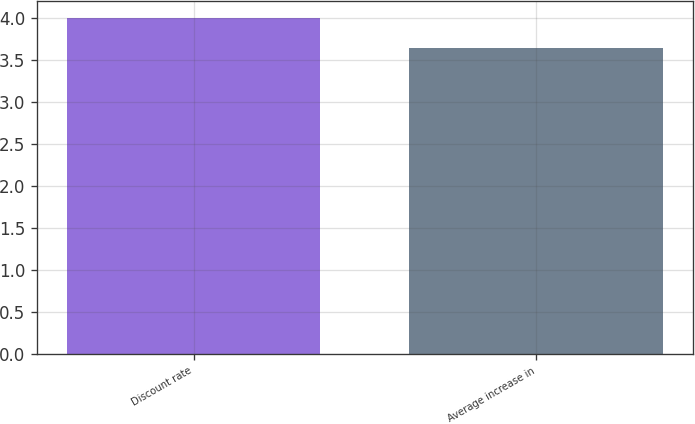Convert chart. <chart><loc_0><loc_0><loc_500><loc_500><bar_chart><fcel>Discount rate<fcel>Average increase in<nl><fcel>4.01<fcel>3.65<nl></chart> 